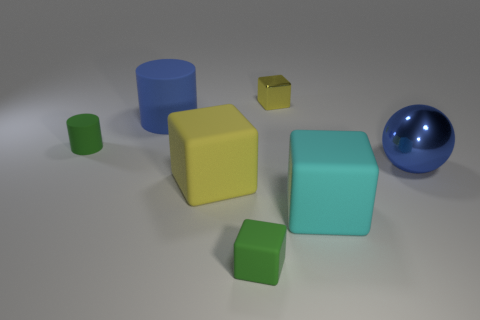Is there any other thing that is the same shape as the blue shiny object?
Your answer should be very brief. No. There is a big thing that is the same color as the big metal ball; what is its material?
Your answer should be compact. Rubber. Is there a blue shiny sphere of the same size as the yellow rubber object?
Provide a succinct answer. Yes. The small rubber cylinder is what color?
Ensure brevity in your answer.  Green. There is a large metallic thing to the right of the yellow thing that is on the right side of the yellow rubber thing; what color is it?
Offer a very short reply. Blue. There is a green thing that is behind the small block in front of the big blue thing that is behind the large blue shiny thing; what is its shape?
Provide a short and direct response. Cylinder. What number of large purple balls have the same material as the large yellow object?
Offer a terse response. 0. What number of large yellow matte cubes are in front of the tiny cube to the left of the small yellow shiny block?
Make the answer very short. 0. What number of rubber objects are there?
Provide a succinct answer. 5. Is the material of the green cylinder the same as the green object right of the yellow rubber thing?
Offer a very short reply. Yes. 